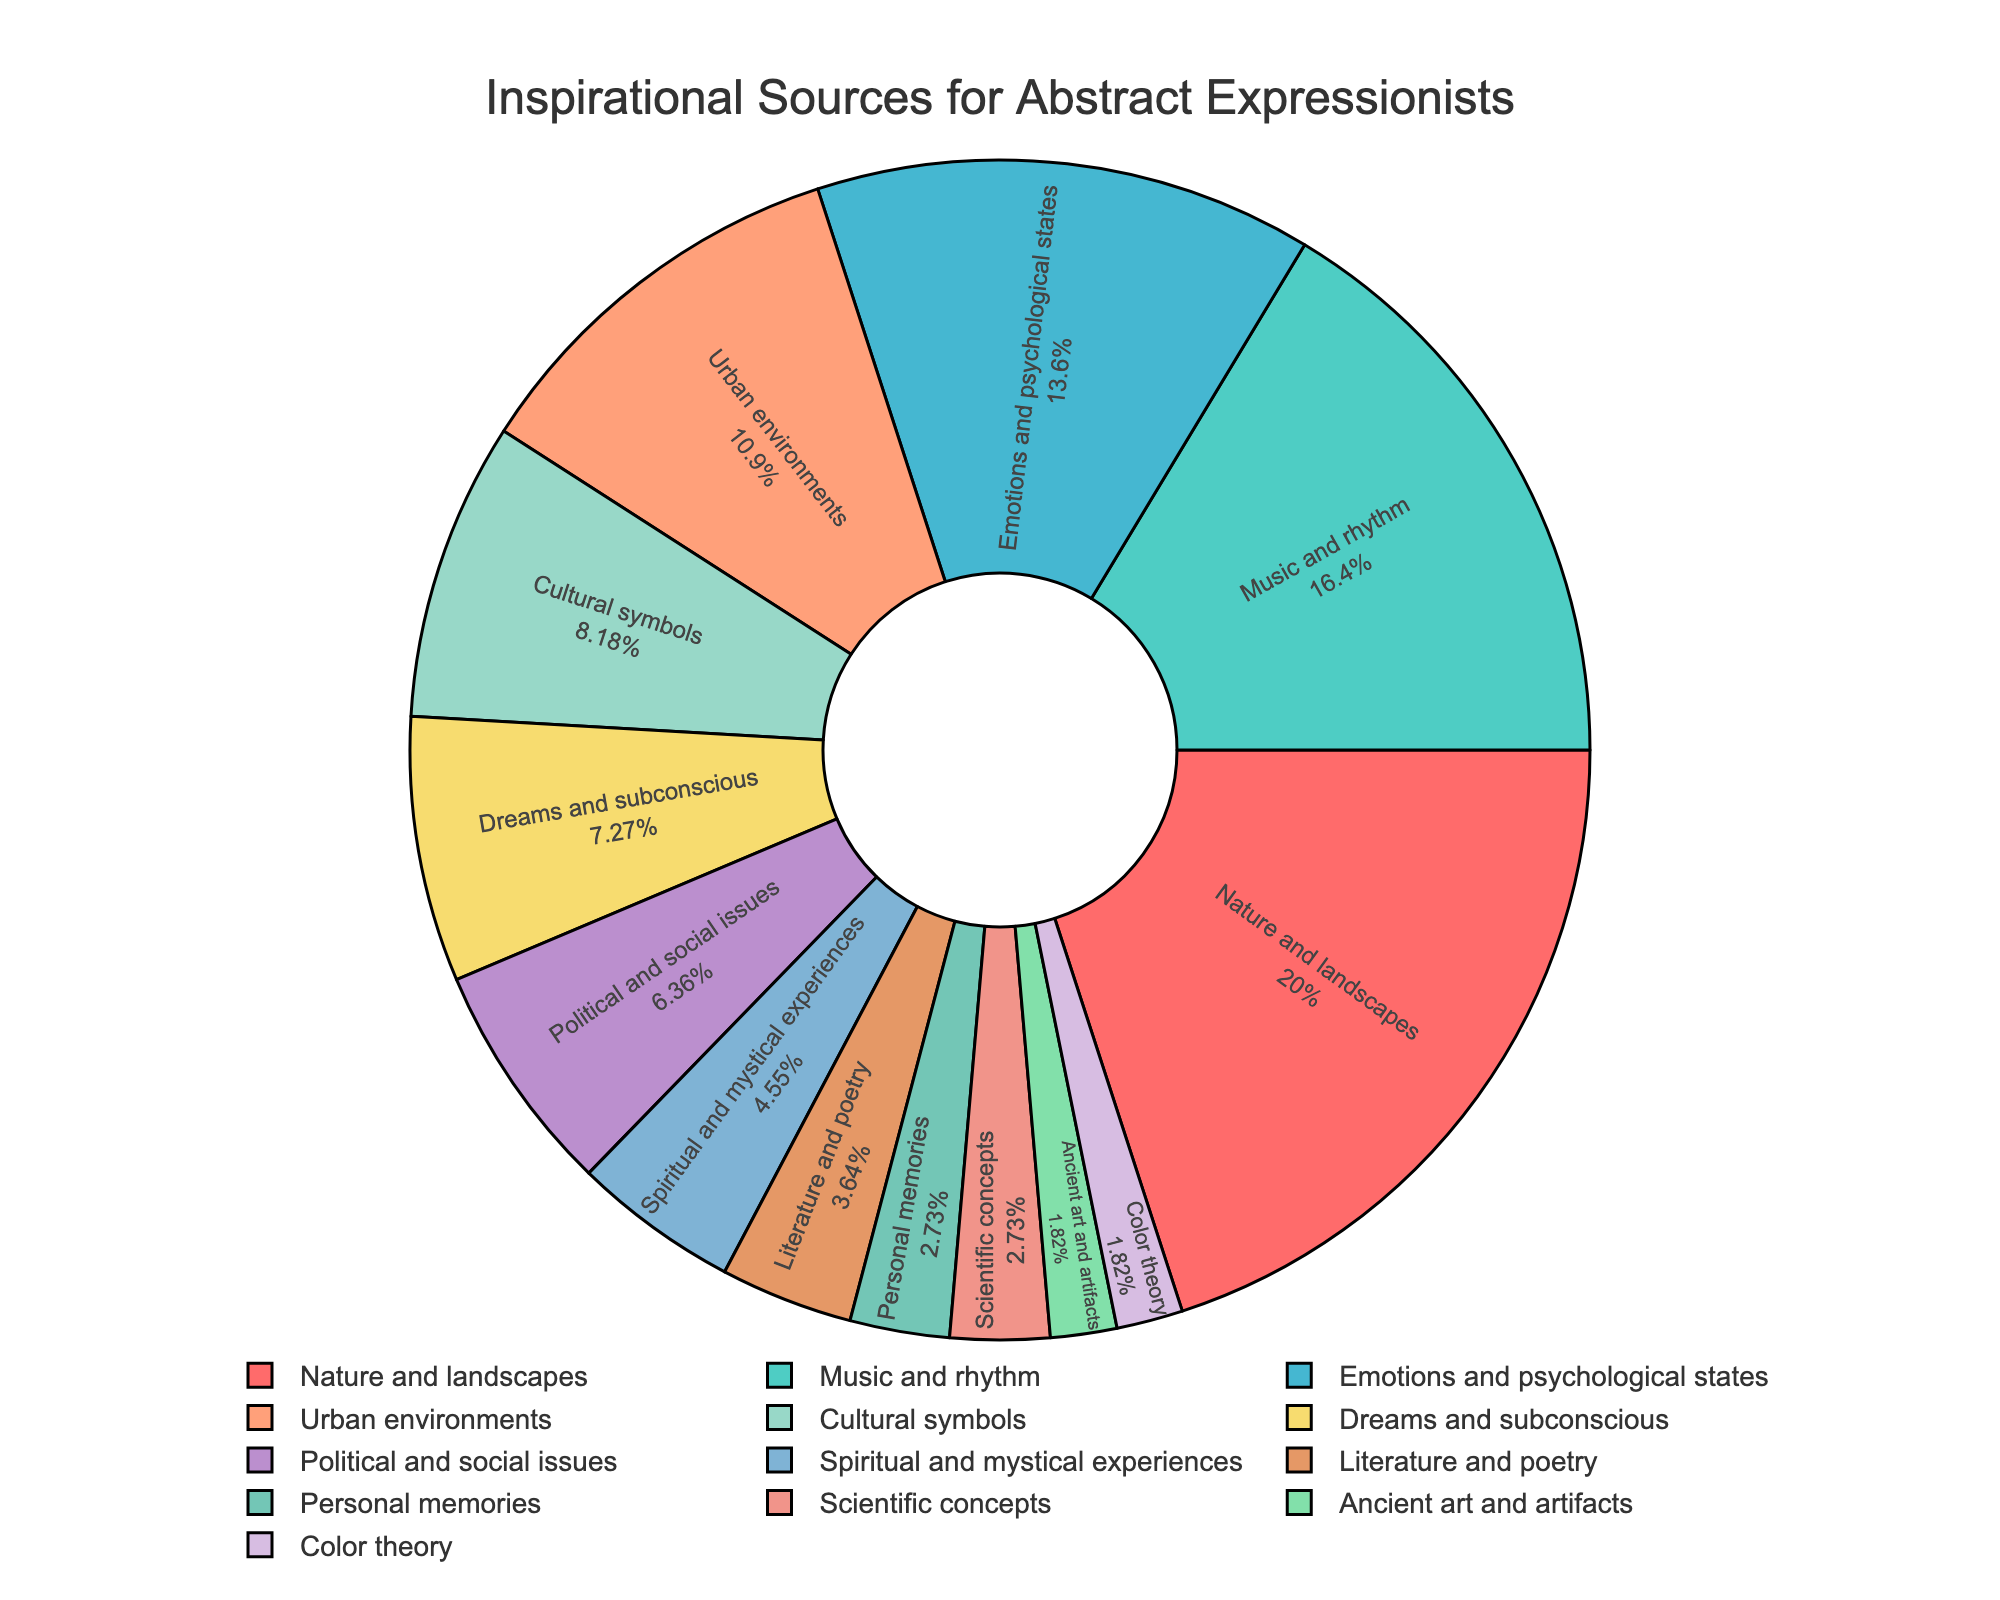what is the most cited inspirational source by the artists? Identify the segment with the largest percentage. The label and percentage inside this segment will show the information. The segment for "Nature and landscapes" is the largest with 22%.
Answer: Nature and landscapes What is the combined percentage of artists citing "Dreams and subconscious" and "Personal memories"? Add the percentages of "Dreams and subconscious" (8%) and "Personal memories" (3%). 8% + 3% = 11%.
Answer: 11% Which inspirational source is less cited: "Ancient art and artifacts" or "Scientific concepts"? Compare the percentages for "Ancient art and artifacts" (2%) and "Scientific concepts" (3%). The "Ancient art and artifacts" segment is smaller.
Answer: Ancient art and artifacts Are there more artists inspired by "Urban environments" or by "Cultural symbols"? Compare the percentages of "Urban environments" (12%) and "Cultural symbols" (9%). The "Urban environments" has a higher percentage.
Answer: Urban environments What is the difference in percentage between artists inspired by "Music and rhythm" and those inspired by "Political and social issues"? Subtract the percentage of "Political and social issues" (7%) from "Music and rhythm" (18%). 18% - 7% = 11%.
Answer: 11% Are there more artists inspired by "Emotions and psychological states" or the combination of "Literature and poetry" and "Color theory"? Compare the percentage of "Emotions and psychological states" (15%) to the sum of "Literature and poetry" (4%) and "Color theory" (2%). 4% + 2% = 6%. 15% > 6%.
Answer: Emotions and psychological states Which has more citations: "Spiritual and mystical experiences" or "Personal memories" combined with "Scientific concepts"? Compare the percentage of "Spiritual and mystical experiences" (5%) with the sum of "Personal memories" (3%) and "Scientific concepts" (3%). 3% + 3% = 6%. The combined value is greater.
Answer: Personal memories and Scientific concepts What is the percentage difference between the most and least cited sources of inspiration? Identify the percentages of the most cited source ("Nature and landscapes" at 22%) and the least cited source ("Ancient art and artifacts" at 2%). Subtract the two values. 22% - 2% = 20%.
Answer: 20% Is "Nature and landscapes" more cited than the sum of "Emotions and psychological states," "Urban environments," and "Cultural symbols"? Sum the percentages of "Emotions and psychological states" (15%), "Urban environments" (12%), and "Cultural symbols" (9%) to get 36%. Compare it with "Nature and landscapes" (22%). 22% < 36%.
Answer: No Which color is assigned to the segment representing "Music and rhythm"? Identify the segment labeled "Music and rhythm" (18%) and observe its color, which is second in the color sequence, a shade of teal.
Answer: Teal 